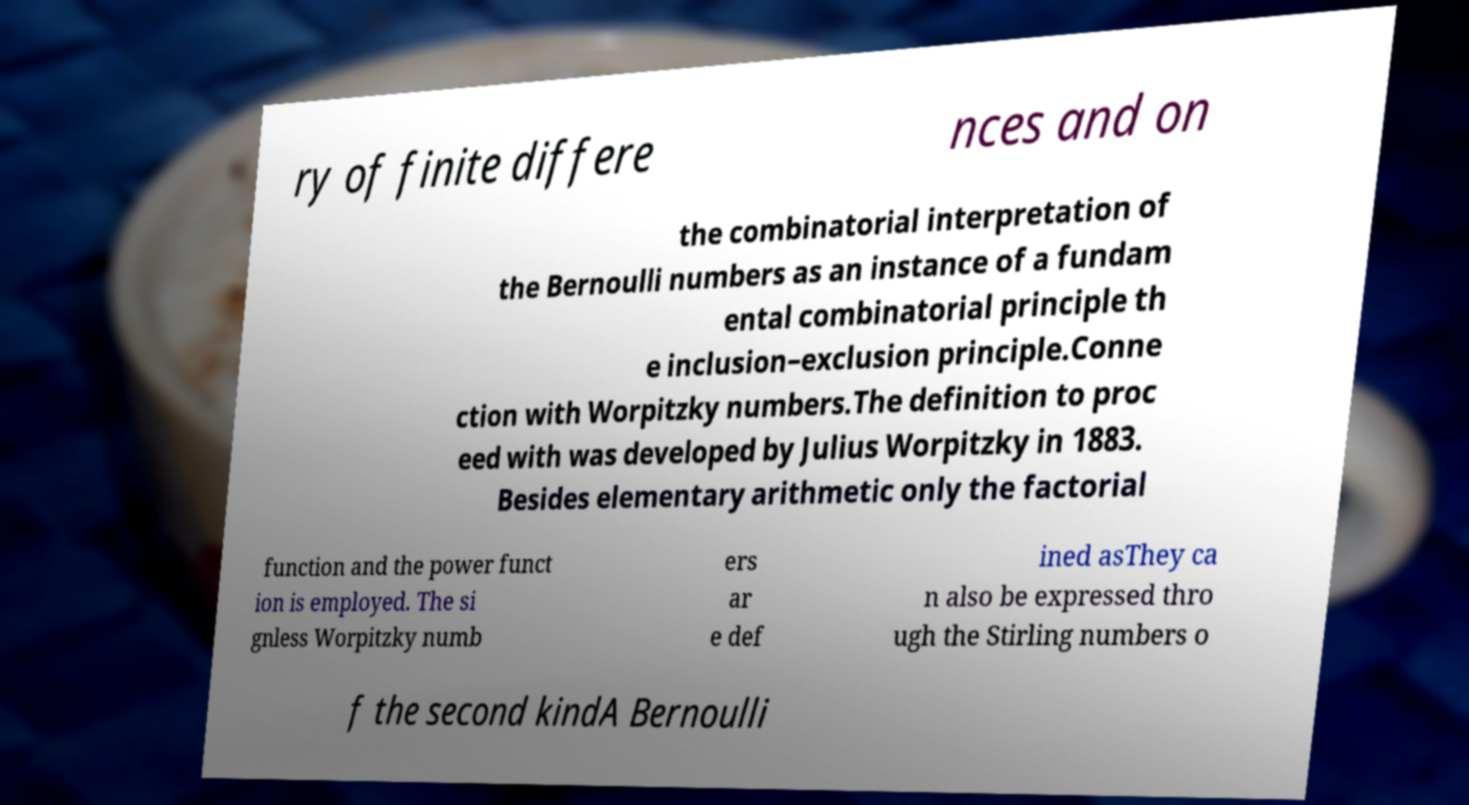Could you assist in decoding the text presented in this image and type it out clearly? ry of finite differe nces and on the combinatorial interpretation of the Bernoulli numbers as an instance of a fundam ental combinatorial principle th e inclusion–exclusion principle.Conne ction with Worpitzky numbers.The definition to proc eed with was developed by Julius Worpitzky in 1883. Besides elementary arithmetic only the factorial function and the power funct ion is employed. The si gnless Worpitzky numb ers ar e def ined asThey ca n also be expressed thro ugh the Stirling numbers o f the second kindA Bernoulli 